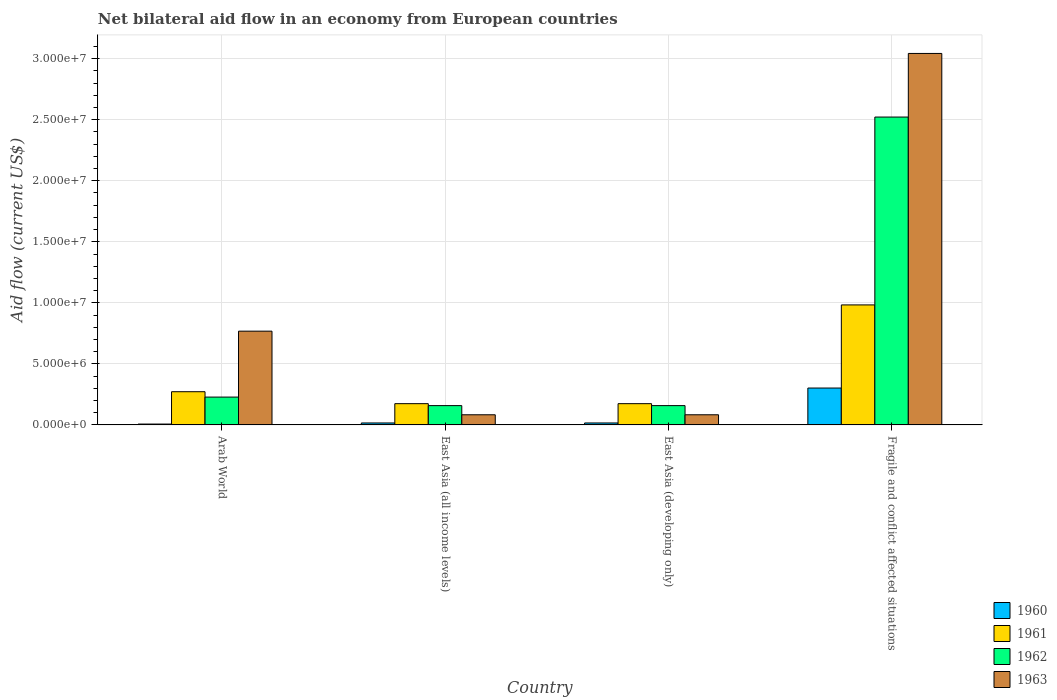How many groups of bars are there?
Keep it short and to the point. 4. Are the number of bars per tick equal to the number of legend labels?
Your answer should be compact. Yes. What is the label of the 1st group of bars from the left?
Provide a succinct answer. Arab World. In how many cases, is the number of bars for a given country not equal to the number of legend labels?
Provide a succinct answer. 0. Across all countries, what is the maximum net bilateral aid flow in 1960?
Offer a very short reply. 3.02e+06. Across all countries, what is the minimum net bilateral aid flow in 1961?
Your answer should be very brief. 1.74e+06. In which country was the net bilateral aid flow in 1963 maximum?
Make the answer very short. Fragile and conflict affected situations. In which country was the net bilateral aid flow in 1962 minimum?
Make the answer very short. East Asia (all income levels). What is the total net bilateral aid flow in 1960 in the graph?
Make the answer very short. 3.41e+06. What is the difference between the net bilateral aid flow in 1960 in East Asia (all income levels) and that in Fragile and conflict affected situations?
Offer a very short reply. -2.86e+06. What is the difference between the net bilateral aid flow in 1960 in East Asia (all income levels) and the net bilateral aid flow in 1962 in Fragile and conflict affected situations?
Your response must be concise. -2.51e+07. What is the average net bilateral aid flow in 1961 per country?
Offer a very short reply. 4.01e+06. What is the difference between the net bilateral aid flow of/in 1960 and net bilateral aid flow of/in 1962 in Fragile and conflict affected situations?
Keep it short and to the point. -2.22e+07. Is the net bilateral aid flow in 1961 in East Asia (all income levels) less than that in East Asia (developing only)?
Give a very brief answer. No. Is the difference between the net bilateral aid flow in 1960 in Arab World and East Asia (developing only) greater than the difference between the net bilateral aid flow in 1962 in Arab World and East Asia (developing only)?
Ensure brevity in your answer.  No. What is the difference between the highest and the second highest net bilateral aid flow in 1963?
Give a very brief answer. 2.28e+07. What is the difference between the highest and the lowest net bilateral aid flow in 1963?
Your response must be concise. 2.96e+07. In how many countries, is the net bilateral aid flow in 1960 greater than the average net bilateral aid flow in 1960 taken over all countries?
Your answer should be very brief. 1. Is the sum of the net bilateral aid flow in 1962 in Arab World and East Asia (developing only) greater than the maximum net bilateral aid flow in 1961 across all countries?
Give a very brief answer. No. Is it the case that in every country, the sum of the net bilateral aid flow in 1963 and net bilateral aid flow in 1962 is greater than the net bilateral aid flow in 1961?
Offer a very short reply. Yes. Are all the bars in the graph horizontal?
Your response must be concise. No. Are the values on the major ticks of Y-axis written in scientific E-notation?
Provide a succinct answer. Yes. Does the graph contain grids?
Your answer should be very brief. Yes. How are the legend labels stacked?
Make the answer very short. Vertical. What is the title of the graph?
Your response must be concise. Net bilateral aid flow in an economy from European countries. Does "1984" appear as one of the legend labels in the graph?
Offer a terse response. No. What is the Aid flow (current US$) in 1961 in Arab World?
Offer a very short reply. 2.72e+06. What is the Aid flow (current US$) in 1962 in Arab World?
Keep it short and to the point. 2.28e+06. What is the Aid flow (current US$) in 1963 in Arab World?
Your response must be concise. 7.68e+06. What is the Aid flow (current US$) in 1961 in East Asia (all income levels)?
Make the answer very short. 1.74e+06. What is the Aid flow (current US$) in 1962 in East Asia (all income levels)?
Your response must be concise. 1.58e+06. What is the Aid flow (current US$) in 1963 in East Asia (all income levels)?
Provide a succinct answer. 8.30e+05. What is the Aid flow (current US$) in 1961 in East Asia (developing only)?
Your answer should be very brief. 1.74e+06. What is the Aid flow (current US$) in 1962 in East Asia (developing only)?
Provide a short and direct response. 1.58e+06. What is the Aid flow (current US$) in 1963 in East Asia (developing only)?
Your answer should be very brief. 8.30e+05. What is the Aid flow (current US$) in 1960 in Fragile and conflict affected situations?
Keep it short and to the point. 3.02e+06. What is the Aid flow (current US$) of 1961 in Fragile and conflict affected situations?
Your response must be concise. 9.83e+06. What is the Aid flow (current US$) of 1962 in Fragile and conflict affected situations?
Provide a succinct answer. 2.52e+07. What is the Aid flow (current US$) of 1963 in Fragile and conflict affected situations?
Offer a very short reply. 3.04e+07. Across all countries, what is the maximum Aid flow (current US$) of 1960?
Keep it short and to the point. 3.02e+06. Across all countries, what is the maximum Aid flow (current US$) in 1961?
Make the answer very short. 9.83e+06. Across all countries, what is the maximum Aid flow (current US$) of 1962?
Ensure brevity in your answer.  2.52e+07. Across all countries, what is the maximum Aid flow (current US$) in 1963?
Provide a short and direct response. 3.04e+07. Across all countries, what is the minimum Aid flow (current US$) of 1960?
Provide a succinct answer. 7.00e+04. Across all countries, what is the minimum Aid flow (current US$) in 1961?
Offer a very short reply. 1.74e+06. Across all countries, what is the minimum Aid flow (current US$) in 1962?
Offer a very short reply. 1.58e+06. Across all countries, what is the minimum Aid flow (current US$) of 1963?
Make the answer very short. 8.30e+05. What is the total Aid flow (current US$) in 1960 in the graph?
Your answer should be very brief. 3.41e+06. What is the total Aid flow (current US$) of 1961 in the graph?
Give a very brief answer. 1.60e+07. What is the total Aid flow (current US$) in 1962 in the graph?
Ensure brevity in your answer.  3.07e+07. What is the total Aid flow (current US$) in 1963 in the graph?
Your response must be concise. 3.98e+07. What is the difference between the Aid flow (current US$) of 1961 in Arab World and that in East Asia (all income levels)?
Your answer should be very brief. 9.80e+05. What is the difference between the Aid flow (current US$) of 1962 in Arab World and that in East Asia (all income levels)?
Your response must be concise. 7.00e+05. What is the difference between the Aid flow (current US$) in 1963 in Arab World and that in East Asia (all income levels)?
Ensure brevity in your answer.  6.85e+06. What is the difference between the Aid flow (current US$) in 1960 in Arab World and that in East Asia (developing only)?
Offer a terse response. -9.00e+04. What is the difference between the Aid flow (current US$) of 1961 in Arab World and that in East Asia (developing only)?
Offer a very short reply. 9.80e+05. What is the difference between the Aid flow (current US$) in 1963 in Arab World and that in East Asia (developing only)?
Offer a terse response. 6.85e+06. What is the difference between the Aid flow (current US$) in 1960 in Arab World and that in Fragile and conflict affected situations?
Keep it short and to the point. -2.95e+06. What is the difference between the Aid flow (current US$) in 1961 in Arab World and that in Fragile and conflict affected situations?
Keep it short and to the point. -7.11e+06. What is the difference between the Aid flow (current US$) of 1962 in Arab World and that in Fragile and conflict affected situations?
Provide a succinct answer. -2.29e+07. What is the difference between the Aid flow (current US$) of 1963 in Arab World and that in Fragile and conflict affected situations?
Offer a terse response. -2.28e+07. What is the difference between the Aid flow (current US$) in 1960 in East Asia (all income levels) and that in East Asia (developing only)?
Provide a succinct answer. 0. What is the difference between the Aid flow (current US$) in 1961 in East Asia (all income levels) and that in East Asia (developing only)?
Offer a terse response. 0. What is the difference between the Aid flow (current US$) of 1962 in East Asia (all income levels) and that in East Asia (developing only)?
Your response must be concise. 0. What is the difference between the Aid flow (current US$) of 1963 in East Asia (all income levels) and that in East Asia (developing only)?
Give a very brief answer. 0. What is the difference between the Aid flow (current US$) in 1960 in East Asia (all income levels) and that in Fragile and conflict affected situations?
Your response must be concise. -2.86e+06. What is the difference between the Aid flow (current US$) in 1961 in East Asia (all income levels) and that in Fragile and conflict affected situations?
Offer a terse response. -8.09e+06. What is the difference between the Aid flow (current US$) in 1962 in East Asia (all income levels) and that in Fragile and conflict affected situations?
Keep it short and to the point. -2.36e+07. What is the difference between the Aid flow (current US$) of 1963 in East Asia (all income levels) and that in Fragile and conflict affected situations?
Your answer should be very brief. -2.96e+07. What is the difference between the Aid flow (current US$) in 1960 in East Asia (developing only) and that in Fragile and conflict affected situations?
Your answer should be very brief. -2.86e+06. What is the difference between the Aid flow (current US$) of 1961 in East Asia (developing only) and that in Fragile and conflict affected situations?
Ensure brevity in your answer.  -8.09e+06. What is the difference between the Aid flow (current US$) in 1962 in East Asia (developing only) and that in Fragile and conflict affected situations?
Offer a terse response. -2.36e+07. What is the difference between the Aid flow (current US$) in 1963 in East Asia (developing only) and that in Fragile and conflict affected situations?
Give a very brief answer. -2.96e+07. What is the difference between the Aid flow (current US$) in 1960 in Arab World and the Aid flow (current US$) in 1961 in East Asia (all income levels)?
Ensure brevity in your answer.  -1.67e+06. What is the difference between the Aid flow (current US$) in 1960 in Arab World and the Aid flow (current US$) in 1962 in East Asia (all income levels)?
Offer a very short reply. -1.51e+06. What is the difference between the Aid flow (current US$) of 1960 in Arab World and the Aid flow (current US$) of 1963 in East Asia (all income levels)?
Your answer should be compact. -7.60e+05. What is the difference between the Aid flow (current US$) of 1961 in Arab World and the Aid flow (current US$) of 1962 in East Asia (all income levels)?
Keep it short and to the point. 1.14e+06. What is the difference between the Aid flow (current US$) in 1961 in Arab World and the Aid flow (current US$) in 1963 in East Asia (all income levels)?
Your response must be concise. 1.89e+06. What is the difference between the Aid flow (current US$) in 1962 in Arab World and the Aid flow (current US$) in 1963 in East Asia (all income levels)?
Provide a succinct answer. 1.45e+06. What is the difference between the Aid flow (current US$) of 1960 in Arab World and the Aid flow (current US$) of 1961 in East Asia (developing only)?
Keep it short and to the point. -1.67e+06. What is the difference between the Aid flow (current US$) in 1960 in Arab World and the Aid flow (current US$) in 1962 in East Asia (developing only)?
Offer a terse response. -1.51e+06. What is the difference between the Aid flow (current US$) of 1960 in Arab World and the Aid flow (current US$) of 1963 in East Asia (developing only)?
Offer a terse response. -7.60e+05. What is the difference between the Aid flow (current US$) in 1961 in Arab World and the Aid flow (current US$) in 1962 in East Asia (developing only)?
Offer a very short reply. 1.14e+06. What is the difference between the Aid flow (current US$) of 1961 in Arab World and the Aid flow (current US$) of 1963 in East Asia (developing only)?
Your response must be concise. 1.89e+06. What is the difference between the Aid flow (current US$) of 1962 in Arab World and the Aid flow (current US$) of 1963 in East Asia (developing only)?
Keep it short and to the point. 1.45e+06. What is the difference between the Aid flow (current US$) of 1960 in Arab World and the Aid flow (current US$) of 1961 in Fragile and conflict affected situations?
Provide a succinct answer. -9.76e+06. What is the difference between the Aid flow (current US$) of 1960 in Arab World and the Aid flow (current US$) of 1962 in Fragile and conflict affected situations?
Your answer should be very brief. -2.52e+07. What is the difference between the Aid flow (current US$) of 1960 in Arab World and the Aid flow (current US$) of 1963 in Fragile and conflict affected situations?
Your response must be concise. -3.04e+07. What is the difference between the Aid flow (current US$) in 1961 in Arab World and the Aid flow (current US$) in 1962 in Fragile and conflict affected situations?
Your answer should be compact. -2.25e+07. What is the difference between the Aid flow (current US$) of 1961 in Arab World and the Aid flow (current US$) of 1963 in Fragile and conflict affected situations?
Your response must be concise. -2.77e+07. What is the difference between the Aid flow (current US$) in 1962 in Arab World and the Aid flow (current US$) in 1963 in Fragile and conflict affected situations?
Your answer should be very brief. -2.82e+07. What is the difference between the Aid flow (current US$) in 1960 in East Asia (all income levels) and the Aid flow (current US$) in 1961 in East Asia (developing only)?
Ensure brevity in your answer.  -1.58e+06. What is the difference between the Aid flow (current US$) in 1960 in East Asia (all income levels) and the Aid flow (current US$) in 1962 in East Asia (developing only)?
Ensure brevity in your answer.  -1.42e+06. What is the difference between the Aid flow (current US$) in 1960 in East Asia (all income levels) and the Aid flow (current US$) in 1963 in East Asia (developing only)?
Provide a short and direct response. -6.70e+05. What is the difference between the Aid flow (current US$) of 1961 in East Asia (all income levels) and the Aid flow (current US$) of 1962 in East Asia (developing only)?
Your response must be concise. 1.60e+05. What is the difference between the Aid flow (current US$) in 1961 in East Asia (all income levels) and the Aid flow (current US$) in 1963 in East Asia (developing only)?
Provide a succinct answer. 9.10e+05. What is the difference between the Aid flow (current US$) of 1962 in East Asia (all income levels) and the Aid flow (current US$) of 1963 in East Asia (developing only)?
Provide a succinct answer. 7.50e+05. What is the difference between the Aid flow (current US$) in 1960 in East Asia (all income levels) and the Aid flow (current US$) in 1961 in Fragile and conflict affected situations?
Your response must be concise. -9.67e+06. What is the difference between the Aid flow (current US$) of 1960 in East Asia (all income levels) and the Aid flow (current US$) of 1962 in Fragile and conflict affected situations?
Your answer should be compact. -2.51e+07. What is the difference between the Aid flow (current US$) of 1960 in East Asia (all income levels) and the Aid flow (current US$) of 1963 in Fragile and conflict affected situations?
Your response must be concise. -3.03e+07. What is the difference between the Aid flow (current US$) of 1961 in East Asia (all income levels) and the Aid flow (current US$) of 1962 in Fragile and conflict affected situations?
Your answer should be very brief. -2.35e+07. What is the difference between the Aid flow (current US$) in 1961 in East Asia (all income levels) and the Aid flow (current US$) in 1963 in Fragile and conflict affected situations?
Your answer should be compact. -2.87e+07. What is the difference between the Aid flow (current US$) of 1962 in East Asia (all income levels) and the Aid flow (current US$) of 1963 in Fragile and conflict affected situations?
Ensure brevity in your answer.  -2.88e+07. What is the difference between the Aid flow (current US$) in 1960 in East Asia (developing only) and the Aid flow (current US$) in 1961 in Fragile and conflict affected situations?
Your answer should be compact. -9.67e+06. What is the difference between the Aid flow (current US$) of 1960 in East Asia (developing only) and the Aid flow (current US$) of 1962 in Fragile and conflict affected situations?
Provide a short and direct response. -2.51e+07. What is the difference between the Aid flow (current US$) in 1960 in East Asia (developing only) and the Aid flow (current US$) in 1963 in Fragile and conflict affected situations?
Provide a succinct answer. -3.03e+07. What is the difference between the Aid flow (current US$) in 1961 in East Asia (developing only) and the Aid flow (current US$) in 1962 in Fragile and conflict affected situations?
Your answer should be compact. -2.35e+07. What is the difference between the Aid flow (current US$) of 1961 in East Asia (developing only) and the Aid flow (current US$) of 1963 in Fragile and conflict affected situations?
Make the answer very short. -2.87e+07. What is the difference between the Aid flow (current US$) of 1962 in East Asia (developing only) and the Aid flow (current US$) of 1963 in Fragile and conflict affected situations?
Give a very brief answer. -2.88e+07. What is the average Aid flow (current US$) of 1960 per country?
Give a very brief answer. 8.52e+05. What is the average Aid flow (current US$) of 1961 per country?
Offer a terse response. 4.01e+06. What is the average Aid flow (current US$) of 1962 per country?
Your answer should be compact. 7.66e+06. What is the average Aid flow (current US$) in 1963 per country?
Offer a very short reply. 9.94e+06. What is the difference between the Aid flow (current US$) in 1960 and Aid flow (current US$) in 1961 in Arab World?
Give a very brief answer. -2.65e+06. What is the difference between the Aid flow (current US$) of 1960 and Aid flow (current US$) of 1962 in Arab World?
Your answer should be very brief. -2.21e+06. What is the difference between the Aid flow (current US$) in 1960 and Aid flow (current US$) in 1963 in Arab World?
Your answer should be compact. -7.61e+06. What is the difference between the Aid flow (current US$) in 1961 and Aid flow (current US$) in 1962 in Arab World?
Provide a short and direct response. 4.40e+05. What is the difference between the Aid flow (current US$) in 1961 and Aid flow (current US$) in 1963 in Arab World?
Keep it short and to the point. -4.96e+06. What is the difference between the Aid flow (current US$) of 1962 and Aid flow (current US$) of 1963 in Arab World?
Ensure brevity in your answer.  -5.40e+06. What is the difference between the Aid flow (current US$) in 1960 and Aid flow (current US$) in 1961 in East Asia (all income levels)?
Your response must be concise. -1.58e+06. What is the difference between the Aid flow (current US$) in 1960 and Aid flow (current US$) in 1962 in East Asia (all income levels)?
Keep it short and to the point. -1.42e+06. What is the difference between the Aid flow (current US$) of 1960 and Aid flow (current US$) of 1963 in East Asia (all income levels)?
Make the answer very short. -6.70e+05. What is the difference between the Aid flow (current US$) of 1961 and Aid flow (current US$) of 1963 in East Asia (all income levels)?
Provide a short and direct response. 9.10e+05. What is the difference between the Aid flow (current US$) in 1962 and Aid flow (current US$) in 1963 in East Asia (all income levels)?
Ensure brevity in your answer.  7.50e+05. What is the difference between the Aid flow (current US$) in 1960 and Aid flow (current US$) in 1961 in East Asia (developing only)?
Keep it short and to the point. -1.58e+06. What is the difference between the Aid flow (current US$) of 1960 and Aid flow (current US$) of 1962 in East Asia (developing only)?
Provide a succinct answer. -1.42e+06. What is the difference between the Aid flow (current US$) of 1960 and Aid flow (current US$) of 1963 in East Asia (developing only)?
Provide a succinct answer. -6.70e+05. What is the difference between the Aid flow (current US$) in 1961 and Aid flow (current US$) in 1962 in East Asia (developing only)?
Your answer should be very brief. 1.60e+05. What is the difference between the Aid flow (current US$) of 1961 and Aid flow (current US$) of 1963 in East Asia (developing only)?
Your answer should be compact. 9.10e+05. What is the difference between the Aid flow (current US$) of 1962 and Aid flow (current US$) of 1963 in East Asia (developing only)?
Your response must be concise. 7.50e+05. What is the difference between the Aid flow (current US$) in 1960 and Aid flow (current US$) in 1961 in Fragile and conflict affected situations?
Keep it short and to the point. -6.81e+06. What is the difference between the Aid flow (current US$) of 1960 and Aid flow (current US$) of 1962 in Fragile and conflict affected situations?
Your answer should be compact. -2.22e+07. What is the difference between the Aid flow (current US$) of 1960 and Aid flow (current US$) of 1963 in Fragile and conflict affected situations?
Provide a short and direct response. -2.74e+07. What is the difference between the Aid flow (current US$) in 1961 and Aid flow (current US$) in 1962 in Fragile and conflict affected situations?
Offer a very short reply. -1.54e+07. What is the difference between the Aid flow (current US$) in 1961 and Aid flow (current US$) in 1963 in Fragile and conflict affected situations?
Ensure brevity in your answer.  -2.06e+07. What is the difference between the Aid flow (current US$) in 1962 and Aid flow (current US$) in 1963 in Fragile and conflict affected situations?
Your answer should be compact. -5.21e+06. What is the ratio of the Aid flow (current US$) in 1960 in Arab World to that in East Asia (all income levels)?
Your response must be concise. 0.44. What is the ratio of the Aid flow (current US$) in 1961 in Arab World to that in East Asia (all income levels)?
Your answer should be very brief. 1.56. What is the ratio of the Aid flow (current US$) of 1962 in Arab World to that in East Asia (all income levels)?
Ensure brevity in your answer.  1.44. What is the ratio of the Aid flow (current US$) of 1963 in Arab World to that in East Asia (all income levels)?
Offer a very short reply. 9.25. What is the ratio of the Aid flow (current US$) of 1960 in Arab World to that in East Asia (developing only)?
Your answer should be very brief. 0.44. What is the ratio of the Aid flow (current US$) of 1961 in Arab World to that in East Asia (developing only)?
Provide a short and direct response. 1.56. What is the ratio of the Aid flow (current US$) in 1962 in Arab World to that in East Asia (developing only)?
Your answer should be compact. 1.44. What is the ratio of the Aid flow (current US$) in 1963 in Arab World to that in East Asia (developing only)?
Offer a very short reply. 9.25. What is the ratio of the Aid flow (current US$) of 1960 in Arab World to that in Fragile and conflict affected situations?
Keep it short and to the point. 0.02. What is the ratio of the Aid flow (current US$) of 1961 in Arab World to that in Fragile and conflict affected situations?
Your response must be concise. 0.28. What is the ratio of the Aid flow (current US$) in 1962 in Arab World to that in Fragile and conflict affected situations?
Your answer should be very brief. 0.09. What is the ratio of the Aid flow (current US$) of 1963 in Arab World to that in Fragile and conflict affected situations?
Make the answer very short. 0.25. What is the ratio of the Aid flow (current US$) in 1960 in East Asia (all income levels) to that in East Asia (developing only)?
Offer a very short reply. 1. What is the ratio of the Aid flow (current US$) of 1963 in East Asia (all income levels) to that in East Asia (developing only)?
Make the answer very short. 1. What is the ratio of the Aid flow (current US$) in 1960 in East Asia (all income levels) to that in Fragile and conflict affected situations?
Offer a very short reply. 0.05. What is the ratio of the Aid flow (current US$) in 1961 in East Asia (all income levels) to that in Fragile and conflict affected situations?
Keep it short and to the point. 0.18. What is the ratio of the Aid flow (current US$) of 1962 in East Asia (all income levels) to that in Fragile and conflict affected situations?
Provide a short and direct response. 0.06. What is the ratio of the Aid flow (current US$) of 1963 in East Asia (all income levels) to that in Fragile and conflict affected situations?
Keep it short and to the point. 0.03. What is the ratio of the Aid flow (current US$) in 1960 in East Asia (developing only) to that in Fragile and conflict affected situations?
Ensure brevity in your answer.  0.05. What is the ratio of the Aid flow (current US$) of 1961 in East Asia (developing only) to that in Fragile and conflict affected situations?
Your answer should be very brief. 0.18. What is the ratio of the Aid flow (current US$) of 1962 in East Asia (developing only) to that in Fragile and conflict affected situations?
Give a very brief answer. 0.06. What is the ratio of the Aid flow (current US$) in 1963 in East Asia (developing only) to that in Fragile and conflict affected situations?
Offer a terse response. 0.03. What is the difference between the highest and the second highest Aid flow (current US$) of 1960?
Make the answer very short. 2.86e+06. What is the difference between the highest and the second highest Aid flow (current US$) in 1961?
Your answer should be very brief. 7.11e+06. What is the difference between the highest and the second highest Aid flow (current US$) in 1962?
Ensure brevity in your answer.  2.29e+07. What is the difference between the highest and the second highest Aid flow (current US$) of 1963?
Make the answer very short. 2.28e+07. What is the difference between the highest and the lowest Aid flow (current US$) of 1960?
Provide a succinct answer. 2.95e+06. What is the difference between the highest and the lowest Aid flow (current US$) of 1961?
Provide a succinct answer. 8.09e+06. What is the difference between the highest and the lowest Aid flow (current US$) of 1962?
Offer a very short reply. 2.36e+07. What is the difference between the highest and the lowest Aid flow (current US$) in 1963?
Your response must be concise. 2.96e+07. 